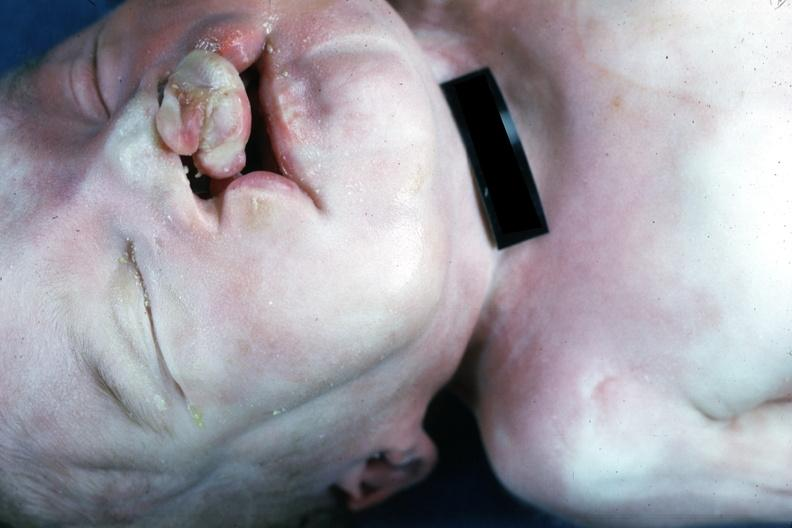does this image show external view bilateral cleft palate?
Answer the question using a single word or phrase. Yes 